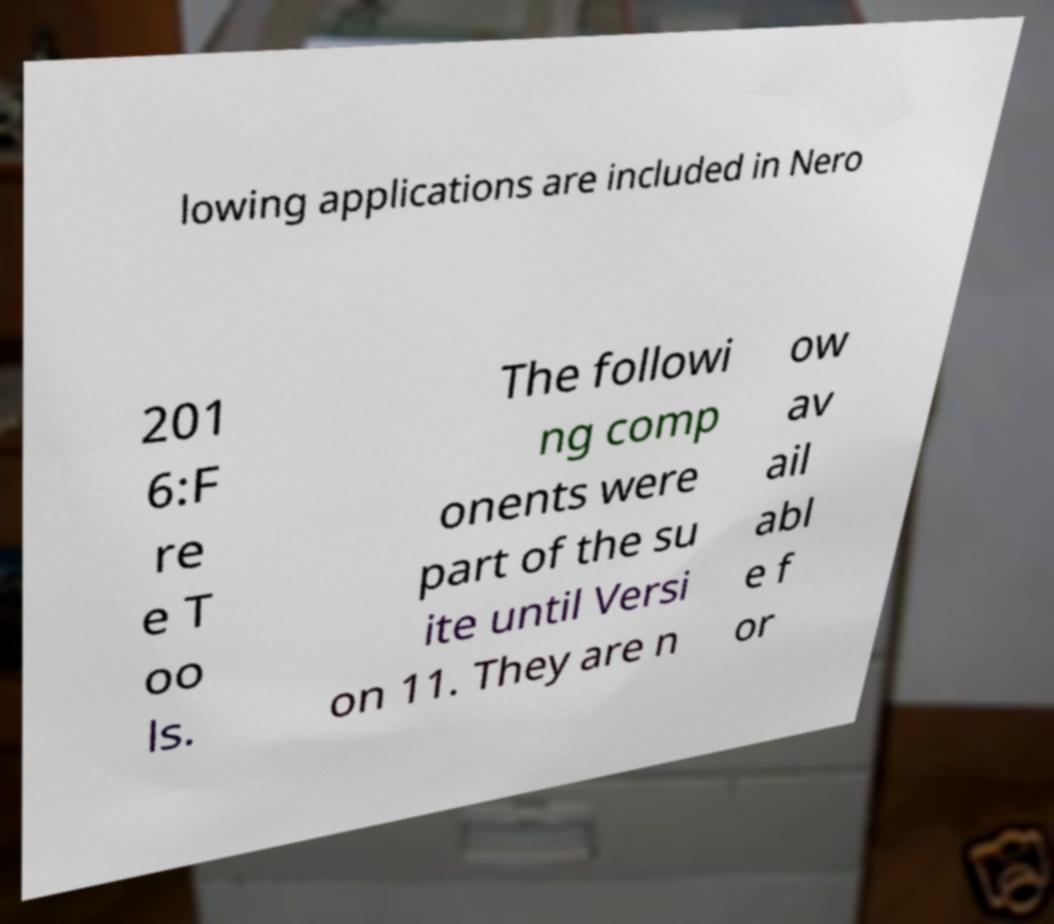For documentation purposes, I need the text within this image transcribed. Could you provide that? lowing applications are included in Nero 201 6:F re e T oo ls. The followi ng comp onents were part of the su ite until Versi on 11. They are n ow av ail abl e f or 